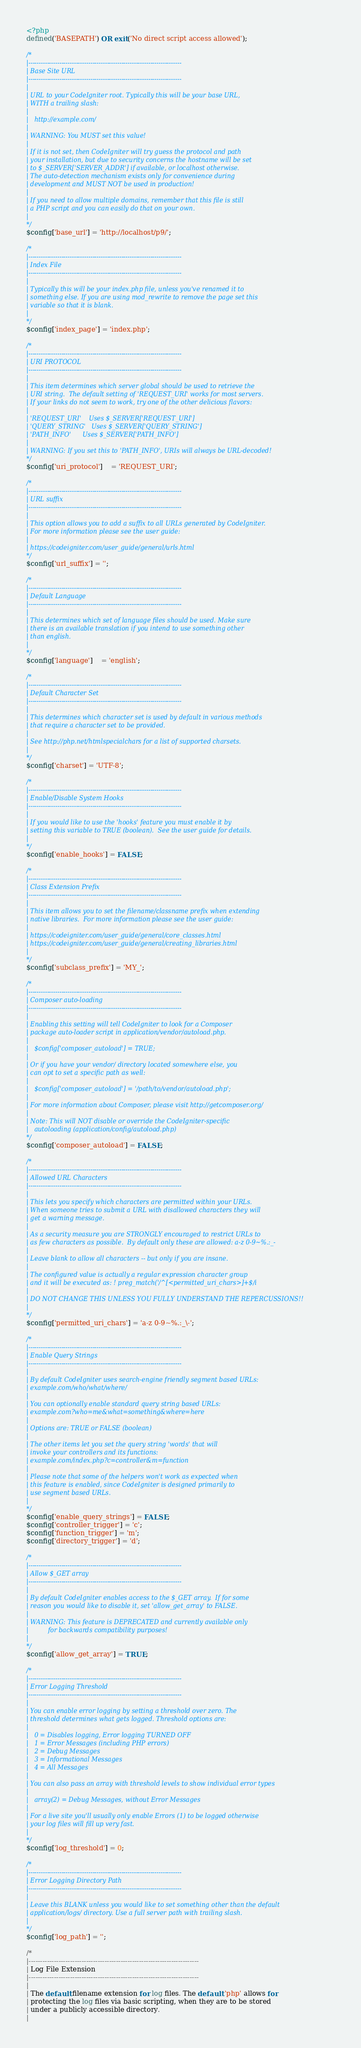<code> <loc_0><loc_0><loc_500><loc_500><_PHP_><?php
defined('BASEPATH') OR exit('No direct script access allowed');

/*
|--------------------------------------------------------------------------
| Base Site URL
|--------------------------------------------------------------------------
|
| URL to your CodeIgniter root. Typically this will be your base URL,
| WITH a trailing slash:
|
|	http://example.com/
|
| WARNING: You MUST set this value!
|
| If it is not set, then CodeIgniter will try guess the protocol and path
| your installation, but due to security concerns the hostname will be set
| to $_SERVER['SERVER_ADDR'] if available, or localhost otherwise.
| The auto-detection mechanism exists only for convenience during
| development and MUST NOT be used in production!
|
| If you need to allow multiple domains, remember that this file is still
| a PHP script and you can easily do that on your own.
|
*/
$config['base_url'] = 'http://localhost/p9/';

/*
|--------------------------------------------------------------------------
| Index File
|--------------------------------------------------------------------------
|
| Typically this will be your index.php file, unless you've renamed it to
| something else. If you are using mod_rewrite to remove the page set this
| variable so that it is blank.
|
*/
$config['index_page'] = 'index.php';

/*
|--------------------------------------------------------------------------
| URI PROTOCOL
|--------------------------------------------------------------------------
|
| This item determines which server global should be used to retrieve the
| URI string.  The default setting of 'REQUEST_URI' works for most servers.
| If your links do not seem to work, try one of the other delicious flavors:
|
| 'REQUEST_URI'    Uses $_SERVER['REQUEST_URI']
| 'QUERY_STRING'   Uses $_SERVER['QUERY_STRING']
| 'PATH_INFO'      Uses $_SERVER['PATH_INFO']
|
| WARNING: If you set this to 'PATH_INFO', URIs will always be URL-decoded!
*/
$config['uri_protocol']	= 'REQUEST_URI';

/*
|--------------------------------------------------------------------------
| URL suffix
|--------------------------------------------------------------------------
|
| This option allows you to add a suffix to all URLs generated by CodeIgniter.
| For more information please see the user guide:
|
| https://codeigniter.com/user_guide/general/urls.html
*/
$config['url_suffix'] = '';

/*
|--------------------------------------------------------------------------
| Default Language
|--------------------------------------------------------------------------
|
| This determines which set of language files should be used. Make sure
| there is an available translation if you intend to use something other
| than english.
|
*/
$config['language']	= 'english';

/*
|--------------------------------------------------------------------------
| Default Character Set
|--------------------------------------------------------------------------
|
| This determines which character set is used by default in various methods
| that require a character set to be provided.
|
| See http://php.net/htmlspecialchars for a list of supported charsets.
|
*/
$config['charset'] = 'UTF-8';

/*
|--------------------------------------------------------------------------
| Enable/Disable System Hooks
|--------------------------------------------------------------------------
|
| If you would like to use the 'hooks' feature you must enable it by
| setting this variable to TRUE (boolean).  See the user guide for details.
|
*/
$config['enable_hooks'] = FALSE;

/*
|--------------------------------------------------------------------------
| Class Extension Prefix
|--------------------------------------------------------------------------
|
| This item allows you to set the filename/classname prefix when extending
| native libraries.  For more information please see the user guide:
|
| https://codeigniter.com/user_guide/general/core_classes.html
| https://codeigniter.com/user_guide/general/creating_libraries.html
|
*/
$config['subclass_prefix'] = 'MY_';

/*
|--------------------------------------------------------------------------
| Composer auto-loading
|--------------------------------------------------------------------------
|
| Enabling this setting will tell CodeIgniter to look for a Composer
| package auto-loader script in application/vendor/autoload.php.
|
|	$config['composer_autoload'] = TRUE;
|
| Or if you have your vendor/ directory located somewhere else, you
| can opt to set a specific path as well:
|
|	$config['composer_autoload'] = '/path/to/vendor/autoload.php';
|
| For more information about Composer, please visit http://getcomposer.org/
|
| Note: This will NOT disable or override the CodeIgniter-specific
|	autoloading (application/config/autoload.php)
*/
$config['composer_autoload'] = FALSE;

/*
|--------------------------------------------------------------------------
| Allowed URL Characters
|--------------------------------------------------------------------------
|
| This lets you specify which characters are permitted within your URLs.
| When someone tries to submit a URL with disallowed characters they will
| get a warning message.
|
| As a security measure you are STRONGLY encouraged to restrict URLs to
| as few characters as possible.  By default only these are allowed: a-z 0-9~%.:_-
|
| Leave blank to allow all characters -- but only if you are insane.
|
| The configured value is actually a regular expression character group
| and it will be executed as: ! preg_match('/^[<permitted_uri_chars>]+$/i
|
| DO NOT CHANGE THIS UNLESS YOU FULLY UNDERSTAND THE REPERCUSSIONS!!
|
*/
$config['permitted_uri_chars'] = 'a-z 0-9~%.:_\-';

/*
|--------------------------------------------------------------------------
| Enable Query Strings
|--------------------------------------------------------------------------
|
| By default CodeIgniter uses search-engine friendly segment based URLs:
| example.com/who/what/where/
|
| You can optionally enable standard query string based URLs:
| example.com?who=me&what=something&where=here
|
| Options are: TRUE or FALSE (boolean)
|
| The other items let you set the query string 'words' that will
| invoke your controllers and its functions:
| example.com/index.php?c=controller&m=function
|
| Please note that some of the helpers won't work as expected when
| this feature is enabled, since CodeIgniter is designed primarily to
| use segment based URLs.
|
*/
$config['enable_query_strings'] = FALSE;
$config['controller_trigger'] = 'c';
$config['function_trigger'] = 'm';
$config['directory_trigger'] = 'd';

/*
|--------------------------------------------------------------------------
| Allow $_GET array
|--------------------------------------------------------------------------
|
| By default CodeIgniter enables access to the $_GET array.  If for some
| reason you would like to disable it, set 'allow_get_array' to FALSE.
|
| WARNING: This feature is DEPRECATED and currently available only
|          for backwards compatibility purposes!
|
*/
$config['allow_get_array'] = TRUE;

/*
|--------------------------------------------------------------------------
| Error Logging Threshold
|--------------------------------------------------------------------------
|
| You can enable error logging by setting a threshold over zero. The
| threshold determines what gets logged. Threshold options are:
|
|	0 = Disables logging, Error logging TURNED OFF
|	1 = Error Messages (including PHP errors)
|	2 = Debug Messages
|	3 = Informational Messages
|	4 = All Messages
|
| You can also pass an array with threshold levels to show individual error types
|
| 	array(2) = Debug Messages, without Error Messages
|
| For a live site you'll usually only enable Errors (1) to be logged otherwise
| your log files will fill up very fast.
|
*/
$config['log_threshold'] = 0;

/*
|--------------------------------------------------------------------------
| Error Logging Directory Path
|--------------------------------------------------------------------------
|
| Leave this BLANK unless you would like to set something other than the default
| application/logs/ directory. Use a full server path with trailing slash.
|
*/
$config['log_path'] = '';

/*
|--------------------------------------------------------------------------
| Log File Extension
|--------------------------------------------------------------------------
|
| The default filename extension for log files. The default 'php' allows for
| protecting the log files via basic scripting, when they are to be stored
| under a publicly accessible directory.
|</code> 